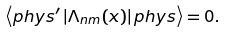<formula> <loc_0><loc_0><loc_500><loc_500>\left \langle p h y s ^ { \prime } \left | \Lambda _ { n m } ( x ) \right | p h y s \right \rangle = 0 .</formula> 